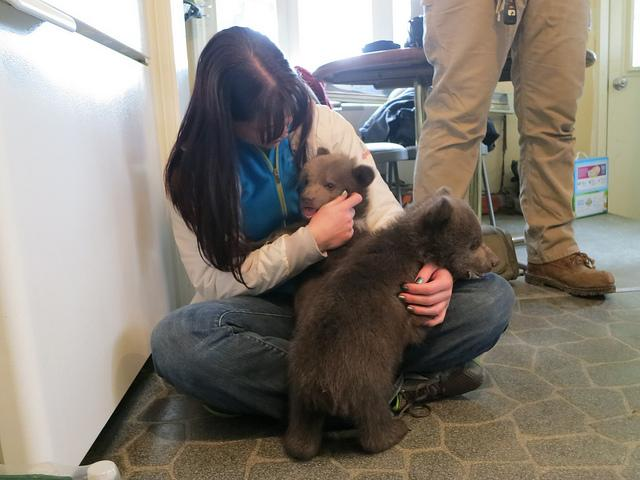The girl is playing with what animals?

Choices:
A) skunks
B) lizards
C) cats
D) bears bears 